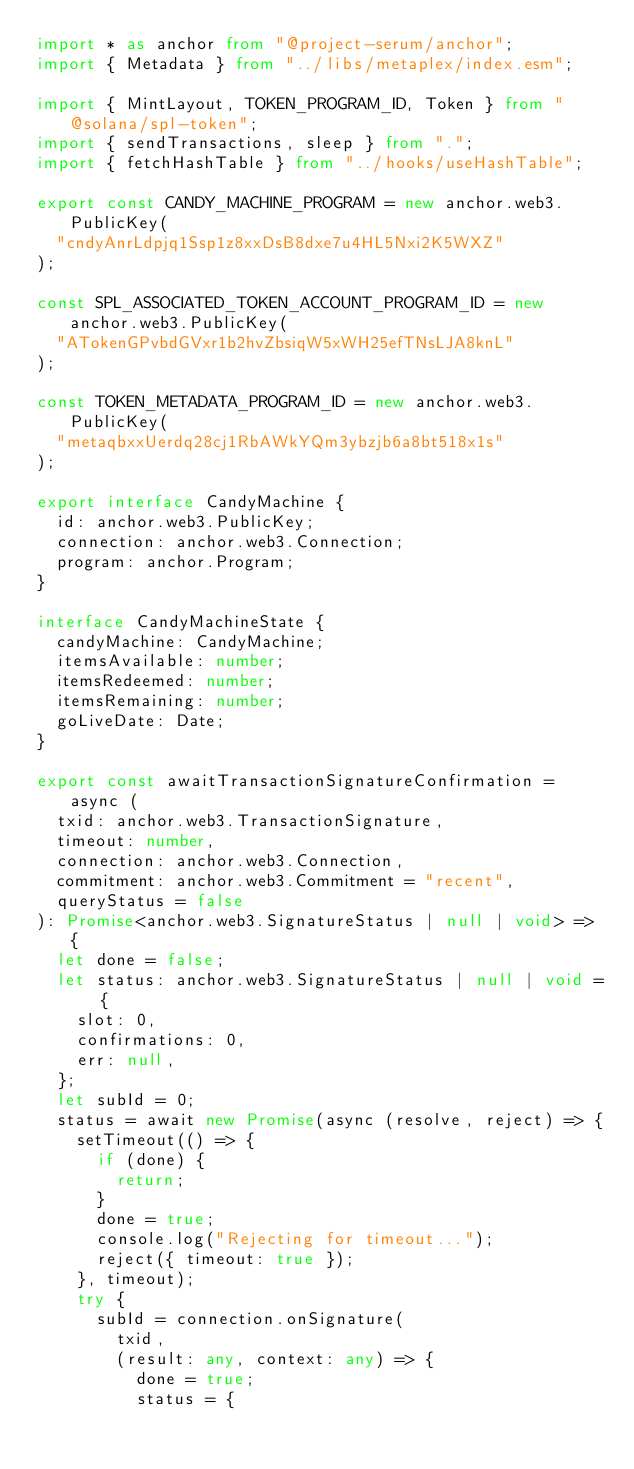Convert code to text. <code><loc_0><loc_0><loc_500><loc_500><_TypeScript_>import * as anchor from "@project-serum/anchor";
import { Metadata } from "../libs/metaplex/index.esm";

import { MintLayout, TOKEN_PROGRAM_ID, Token } from "@solana/spl-token";
import { sendTransactions, sleep } from ".";
import { fetchHashTable } from "../hooks/useHashTable";

export const CANDY_MACHINE_PROGRAM = new anchor.web3.PublicKey(
  "cndyAnrLdpjq1Ssp1z8xxDsB8dxe7u4HL5Nxi2K5WXZ"
);

const SPL_ASSOCIATED_TOKEN_ACCOUNT_PROGRAM_ID = new anchor.web3.PublicKey(
  "ATokenGPvbdGVxr1b2hvZbsiqW5xWH25efTNsLJA8knL"
);

const TOKEN_METADATA_PROGRAM_ID = new anchor.web3.PublicKey(
  "metaqbxxUerdq28cj1RbAWkYQm3ybzjb6a8bt518x1s"
);

export interface CandyMachine {
  id: anchor.web3.PublicKey;
  connection: anchor.web3.Connection;
  program: anchor.Program;
}

interface CandyMachineState {
  candyMachine: CandyMachine;
  itemsAvailable: number;
  itemsRedeemed: number;
  itemsRemaining: number;
  goLiveDate: Date;
}

export const awaitTransactionSignatureConfirmation = async (
  txid: anchor.web3.TransactionSignature,
  timeout: number,
  connection: anchor.web3.Connection,
  commitment: anchor.web3.Commitment = "recent",
  queryStatus = false
): Promise<anchor.web3.SignatureStatus | null | void> => {
  let done = false;
  let status: anchor.web3.SignatureStatus | null | void = {
    slot: 0,
    confirmations: 0,
    err: null,
  };
  let subId = 0;
  status = await new Promise(async (resolve, reject) => {
    setTimeout(() => {
      if (done) {
        return;
      }
      done = true;
      console.log("Rejecting for timeout...");
      reject({ timeout: true });
    }, timeout);
    try {
      subId = connection.onSignature(
        txid,
        (result: any, context: any) => {
          done = true;
          status = {</code> 